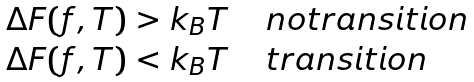Convert formula to latex. <formula><loc_0><loc_0><loc_500><loc_500>\begin{array} { c l } \Delta F ( f , T ) > k _ { B } T & \ \ n o t r a n s i t i o n \\ \Delta F ( f , T ) < k _ { B } T & \ \ t r a n s i t i o n \\ \end{array}</formula> 